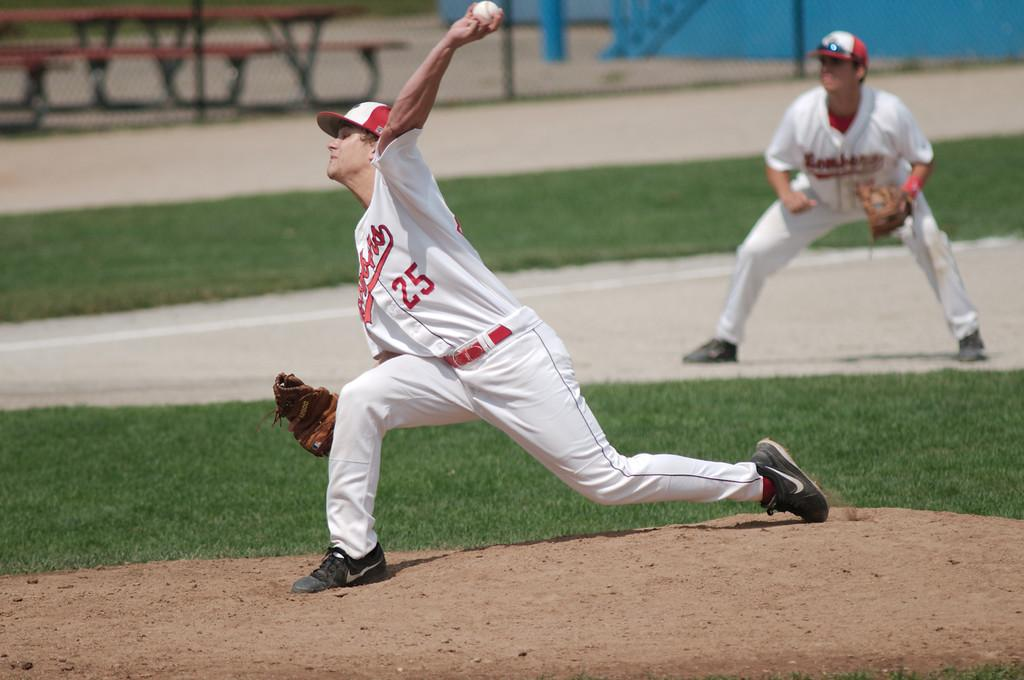Provide a one-sentence caption for the provided image. A man with a baseball uniform with the number 25 on it is in the process of throwing a ball. 